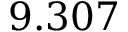<formula> <loc_0><loc_0><loc_500><loc_500>9 . 3 0 7</formula> 